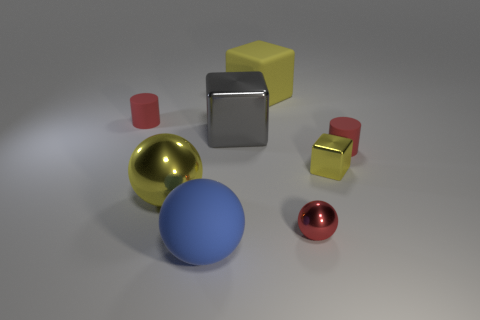Add 1 tiny red objects. How many objects exist? 9 Subtract all spheres. How many objects are left? 5 Subtract 0 red cubes. How many objects are left? 8 Subtract all large gray shiny cubes. Subtract all spheres. How many objects are left? 4 Add 1 big yellow metal things. How many big yellow metal things are left? 2 Add 5 small blue things. How many small blue things exist? 5 